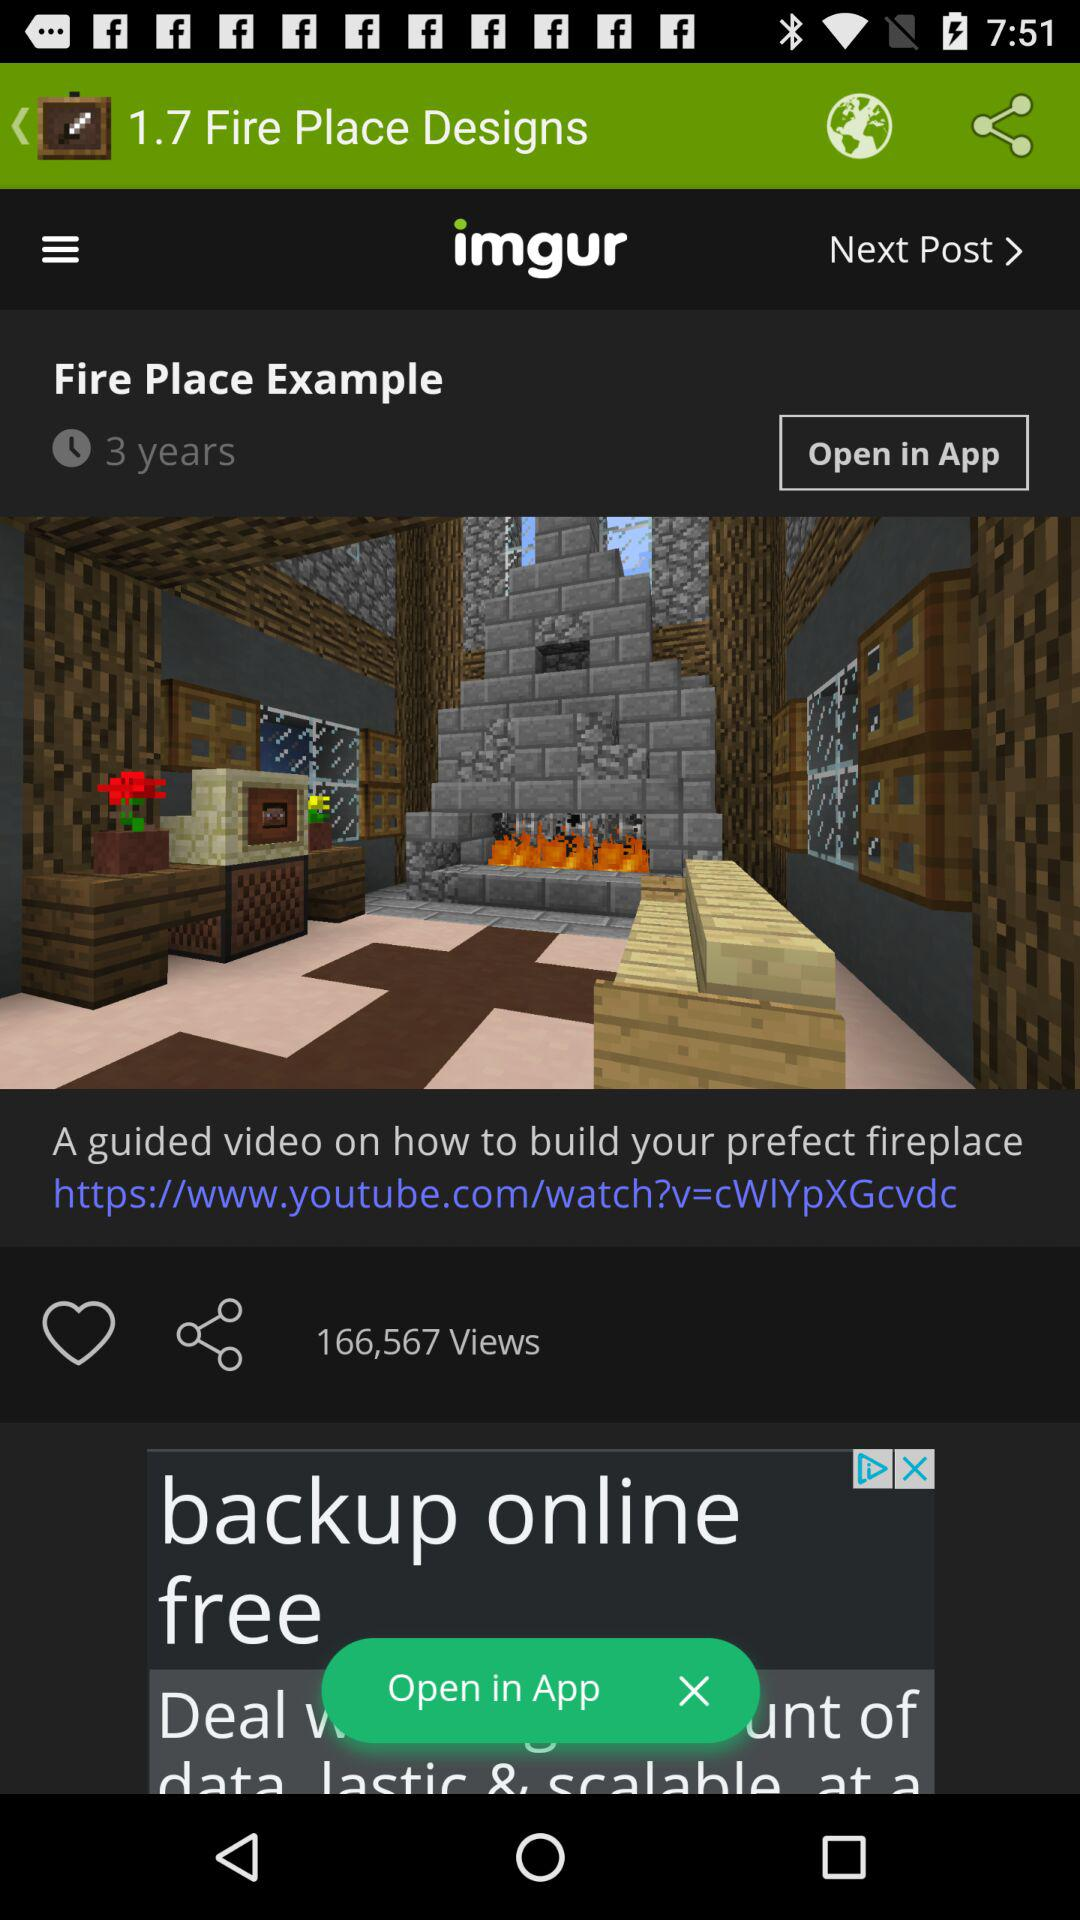How many views did the "Fire Place Example" post get? The "Fire Place Example" post got 166,567 views. 